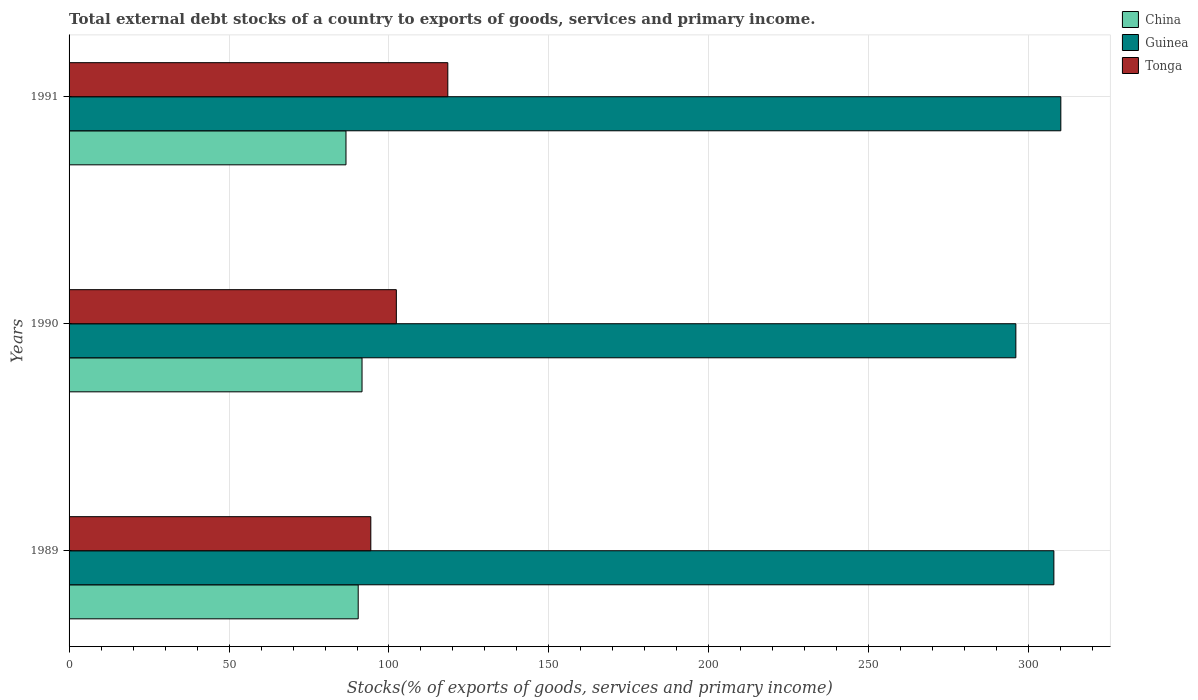How many different coloured bars are there?
Ensure brevity in your answer.  3. Are the number of bars per tick equal to the number of legend labels?
Your response must be concise. Yes. What is the total debt stocks in Guinea in 1991?
Your answer should be very brief. 310. Across all years, what is the maximum total debt stocks in Tonga?
Ensure brevity in your answer.  118.39. Across all years, what is the minimum total debt stocks in Tonga?
Provide a short and direct response. 94.32. In which year was the total debt stocks in China maximum?
Provide a succinct answer. 1990. What is the total total debt stocks in China in the graph?
Provide a succinct answer. 268.51. What is the difference between the total debt stocks in China in 1989 and that in 1990?
Provide a short and direct response. -1.2. What is the difference between the total debt stocks in Guinea in 1990 and the total debt stocks in China in 1991?
Offer a terse response. 209.39. What is the average total debt stocks in Guinea per year?
Give a very brief answer. 304.6. In the year 1991, what is the difference between the total debt stocks in China and total debt stocks in Tonga?
Provide a succinct answer. -31.83. In how many years, is the total debt stocks in Tonga greater than 300 %?
Provide a succinct answer. 0. What is the ratio of the total debt stocks in China in 1990 to that in 1991?
Your answer should be compact. 1.06. Is the total debt stocks in China in 1989 less than that in 1991?
Keep it short and to the point. No. What is the difference between the highest and the second highest total debt stocks in Tonga?
Your answer should be very brief. 16.08. What is the difference between the highest and the lowest total debt stocks in Guinea?
Offer a very short reply. 14.06. What does the 1st bar from the top in 1991 represents?
Ensure brevity in your answer.  Tonga. What does the 1st bar from the bottom in 1989 represents?
Your answer should be compact. China. How many bars are there?
Offer a very short reply. 9. How many years are there in the graph?
Your answer should be very brief. 3. Does the graph contain grids?
Offer a very short reply. Yes. Where does the legend appear in the graph?
Provide a short and direct response. Top right. How are the legend labels stacked?
Make the answer very short. Vertical. What is the title of the graph?
Make the answer very short. Total external debt stocks of a country to exports of goods, services and primary income. What is the label or title of the X-axis?
Keep it short and to the point. Stocks(% of exports of goods, services and primary income). What is the label or title of the Y-axis?
Give a very brief answer. Years. What is the Stocks(% of exports of goods, services and primary income) in China in 1989?
Give a very brief answer. 90.38. What is the Stocks(% of exports of goods, services and primary income) in Guinea in 1989?
Your response must be concise. 307.83. What is the Stocks(% of exports of goods, services and primary income) of Tonga in 1989?
Provide a succinct answer. 94.32. What is the Stocks(% of exports of goods, services and primary income) of China in 1990?
Offer a very short reply. 91.57. What is the Stocks(% of exports of goods, services and primary income) of Guinea in 1990?
Your response must be concise. 295.95. What is the Stocks(% of exports of goods, services and primary income) of Tonga in 1990?
Offer a very short reply. 102.3. What is the Stocks(% of exports of goods, services and primary income) of China in 1991?
Provide a short and direct response. 86.56. What is the Stocks(% of exports of goods, services and primary income) in Guinea in 1991?
Make the answer very short. 310. What is the Stocks(% of exports of goods, services and primary income) in Tonga in 1991?
Provide a short and direct response. 118.39. Across all years, what is the maximum Stocks(% of exports of goods, services and primary income) in China?
Provide a succinct answer. 91.57. Across all years, what is the maximum Stocks(% of exports of goods, services and primary income) of Guinea?
Offer a terse response. 310. Across all years, what is the maximum Stocks(% of exports of goods, services and primary income) in Tonga?
Offer a terse response. 118.39. Across all years, what is the minimum Stocks(% of exports of goods, services and primary income) of China?
Give a very brief answer. 86.56. Across all years, what is the minimum Stocks(% of exports of goods, services and primary income) of Guinea?
Your answer should be compact. 295.95. Across all years, what is the minimum Stocks(% of exports of goods, services and primary income) in Tonga?
Ensure brevity in your answer.  94.32. What is the total Stocks(% of exports of goods, services and primary income) of China in the graph?
Provide a short and direct response. 268.51. What is the total Stocks(% of exports of goods, services and primary income) of Guinea in the graph?
Your answer should be very brief. 913.79. What is the total Stocks(% of exports of goods, services and primary income) in Tonga in the graph?
Ensure brevity in your answer.  315.01. What is the difference between the Stocks(% of exports of goods, services and primary income) in China in 1989 and that in 1990?
Offer a very short reply. -1.2. What is the difference between the Stocks(% of exports of goods, services and primary income) of Guinea in 1989 and that in 1990?
Your response must be concise. 11.88. What is the difference between the Stocks(% of exports of goods, services and primary income) in Tonga in 1989 and that in 1990?
Keep it short and to the point. -7.98. What is the difference between the Stocks(% of exports of goods, services and primary income) of China in 1989 and that in 1991?
Make the answer very short. 3.82. What is the difference between the Stocks(% of exports of goods, services and primary income) of Guinea in 1989 and that in 1991?
Give a very brief answer. -2.17. What is the difference between the Stocks(% of exports of goods, services and primary income) in Tonga in 1989 and that in 1991?
Your answer should be compact. -24.07. What is the difference between the Stocks(% of exports of goods, services and primary income) in China in 1990 and that in 1991?
Provide a short and direct response. 5.01. What is the difference between the Stocks(% of exports of goods, services and primary income) of Guinea in 1990 and that in 1991?
Provide a short and direct response. -14.06. What is the difference between the Stocks(% of exports of goods, services and primary income) of Tonga in 1990 and that in 1991?
Your answer should be very brief. -16.08. What is the difference between the Stocks(% of exports of goods, services and primary income) in China in 1989 and the Stocks(% of exports of goods, services and primary income) in Guinea in 1990?
Your answer should be compact. -205.57. What is the difference between the Stocks(% of exports of goods, services and primary income) of China in 1989 and the Stocks(% of exports of goods, services and primary income) of Tonga in 1990?
Your answer should be very brief. -11.93. What is the difference between the Stocks(% of exports of goods, services and primary income) of Guinea in 1989 and the Stocks(% of exports of goods, services and primary income) of Tonga in 1990?
Ensure brevity in your answer.  205.53. What is the difference between the Stocks(% of exports of goods, services and primary income) in China in 1989 and the Stocks(% of exports of goods, services and primary income) in Guinea in 1991?
Make the answer very short. -219.63. What is the difference between the Stocks(% of exports of goods, services and primary income) of China in 1989 and the Stocks(% of exports of goods, services and primary income) of Tonga in 1991?
Keep it short and to the point. -28.01. What is the difference between the Stocks(% of exports of goods, services and primary income) of Guinea in 1989 and the Stocks(% of exports of goods, services and primary income) of Tonga in 1991?
Make the answer very short. 189.45. What is the difference between the Stocks(% of exports of goods, services and primary income) of China in 1990 and the Stocks(% of exports of goods, services and primary income) of Guinea in 1991?
Your answer should be very brief. -218.43. What is the difference between the Stocks(% of exports of goods, services and primary income) of China in 1990 and the Stocks(% of exports of goods, services and primary income) of Tonga in 1991?
Your answer should be compact. -26.81. What is the difference between the Stocks(% of exports of goods, services and primary income) of Guinea in 1990 and the Stocks(% of exports of goods, services and primary income) of Tonga in 1991?
Offer a very short reply. 177.56. What is the average Stocks(% of exports of goods, services and primary income) of China per year?
Provide a succinct answer. 89.5. What is the average Stocks(% of exports of goods, services and primary income) in Guinea per year?
Offer a terse response. 304.6. What is the average Stocks(% of exports of goods, services and primary income) in Tonga per year?
Ensure brevity in your answer.  105. In the year 1989, what is the difference between the Stocks(% of exports of goods, services and primary income) in China and Stocks(% of exports of goods, services and primary income) in Guinea?
Your answer should be very brief. -217.46. In the year 1989, what is the difference between the Stocks(% of exports of goods, services and primary income) of China and Stocks(% of exports of goods, services and primary income) of Tonga?
Your answer should be very brief. -3.94. In the year 1989, what is the difference between the Stocks(% of exports of goods, services and primary income) in Guinea and Stocks(% of exports of goods, services and primary income) in Tonga?
Your answer should be very brief. 213.51. In the year 1990, what is the difference between the Stocks(% of exports of goods, services and primary income) of China and Stocks(% of exports of goods, services and primary income) of Guinea?
Keep it short and to the point. -204.38. In the year 1990, what is the difference between the Stocks(% of exports of goods, services and primary income) of China and Stocks(% of exports of goods, services and primary income) of Tonga?
Your response must be concise. -10.73. In the year 1990, what is the difference between the Stocks(% of exports of goods, services and primary income) of Guinea and Stocks(% of exports of goods, services and primary income) of Tonga?
Your answer should be compact. 193.65. In the year 1991, what is the difference between the Stocks(% of exports of goods, services and primary income) in China and Stocks(% of exports of goods, services and primary income) in Guinea?
Provide a succinct answer. -223.45. In the year 1991, what is the difference between the Stocks(% of exports of goods, services and primary income) of China and Stocks(% of exports of goods, services and primary income) of Tonga?
Keep it short and to the point. -31.83. In the year 1991, what is the difference between the Stocks(% of exports of goods, services and primary income) of Guinea and Stocks(% of exports of goods, services and primary income) of Tonga?
Your answer should be compact. 191.62. What is the ratio of the Stocks(% of exports of goods, services and primary income) of China in 1989 to that in 1990?
Provide a short and direct response. 0.99. What is the ratio of the Stocks(% of exports of goods, services and primary income) in Guinea in 1989 to that in 1990?
Your answer should be very brief. 1.04. What is the ratio of the Stocks(% of exports of goods, services and primary income) of Tonga in 1989 to that in 1990?
Provide a short and direct response. 0.92. What is the ratio of the Stocks(% of exports of goods, services and primary income) in China in 1989 to that in 1991?
Offer a very short reply. 1.04. What is the ratio of the Stocks(% of exports of goods, services and primary income) of Guinea in 1989 to that in 1991?
Provide a succinct answer. 0.99. What is the ratio of the Stocks(% of exports of goods, services and primary income) of Tonga in 1989 to that in 1991?
Make the answer very short. 0.8. What is the ratio of the Stocks(% of exports of goods, services and primary income) in China in 1990 to that in 1991?
Your answer should be very brief. 1.06. What is the ratio of the Stocks(% of exports of goods, services and primary income) in Guinea in 1990 to that in 1991?
Provide a short and direct response. 0.95. What is the ratio of the Stocks(% of exports of goods, services and primary income) of Tonga in 1990 to that in 1991?
Your answer should be compact. 0.86. What is the difference between the highest and the second highest Stocks(% of exports of goods, services and primary income) in China?
Provide a short and direct response. 1.2. What is the difference between the highest and the second highest Stocks(% of exports of goods, services and primary income) of Guinea?
Provide a succinct answer. 2.17. What is the difference between the highest and the second highest Stocks(% of exports of goods, services and primary income) in Tonga?
Give a very brief answer. 16.08. What is the difference between the highest and the lowest Stocks(% of exports of goods, services and primary income) in China?
Make the answer very short. 5.01. What is the difference between the highest and the lowest Stocks(% of exports of goods, services and primary income) of Guinea?
Provide a succinct answer. 14.06. What is the difference between the highest and the lowest Stocks(% of exports of goods, services and primary income) of Tonga?
Provide a succinct answer. 24.07. 